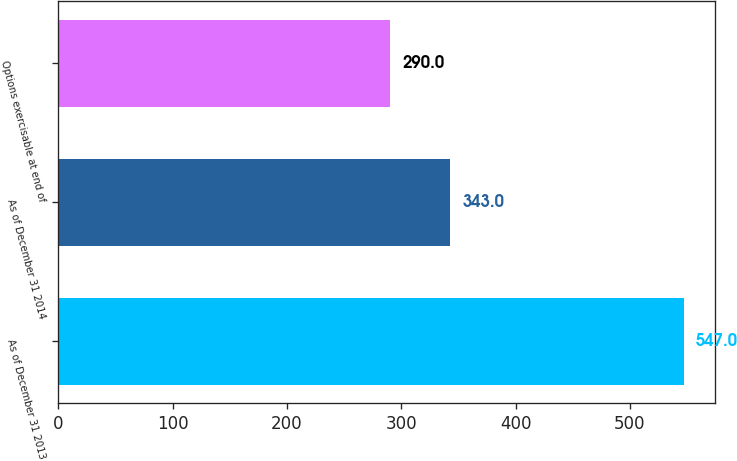Convert chart to OTSL. <chart><loc_0><loc_0><loc_500><loc_500><bar_chart><fcel>As of December 31 2013<fcel>As of December 31 2014<fcel>Options exercisable at end of<nl><fcel>547<fcel>343<fcel>290<nl></chart> 